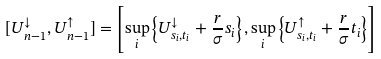Convert formula to latex. <formula><loc_0><loc_0><loc_500><loc_500>[ U ^ { \downarrow } _ { n - 1 } , U ^ { \uparrow } _ { n - 1 } ] = \left [ \sup _ { i } \left \{ U ^ { \downarrow } _ { s _ { i } , t _ { i } } + \frac { r } { \sigma } s _ { i } \right \} , \sup _ { i } \left \{ U ^ { \uparrow } _ { s _ { i } , t _ { i } } + \frac { r } { \sigma } t _ { i } \right \} \right ]</formula> 